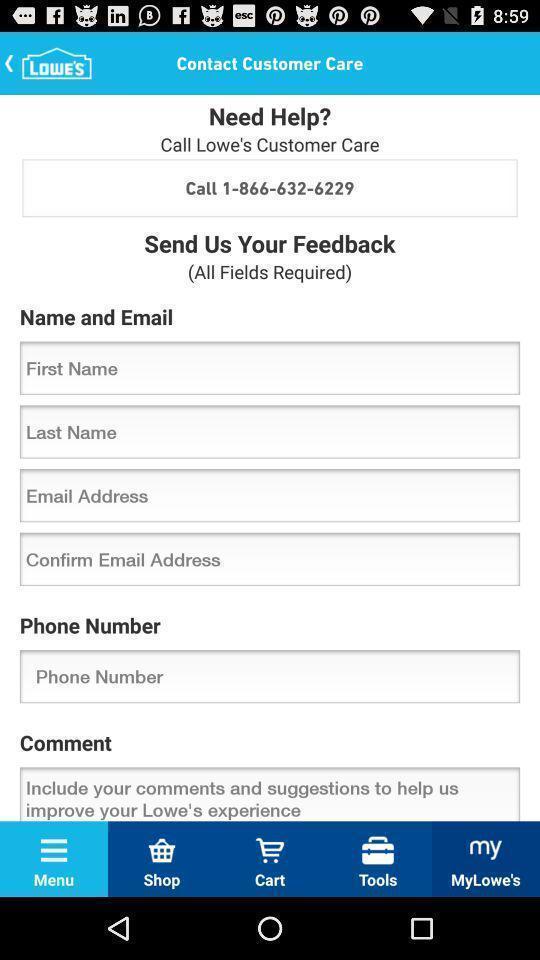Provide a description of this screenshot. Welcome page. 